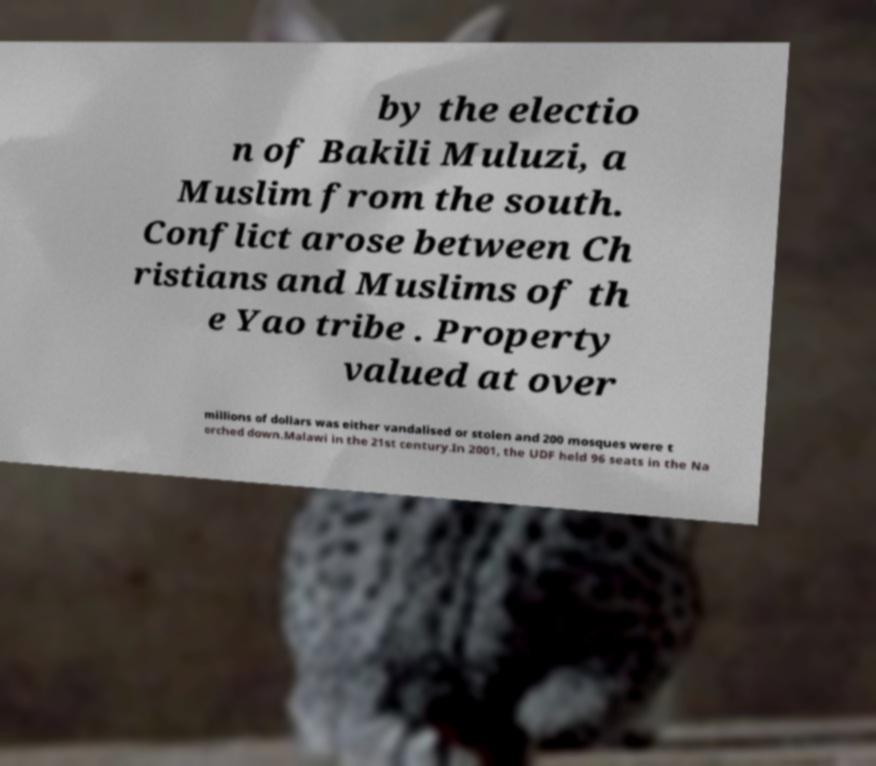Could you extract and type out the text from this image? by the electio n of Bakili Muluzi, a Muslim from the south. Conflict arose between Ch ristians and Muslims of th e Yao tribe . Property valued at over millions of dollars was either vandalised or stolen and 200 mosques were t orched down.Malawi in the 21st century.In 2001, the UDF held 96 seats in the Na 